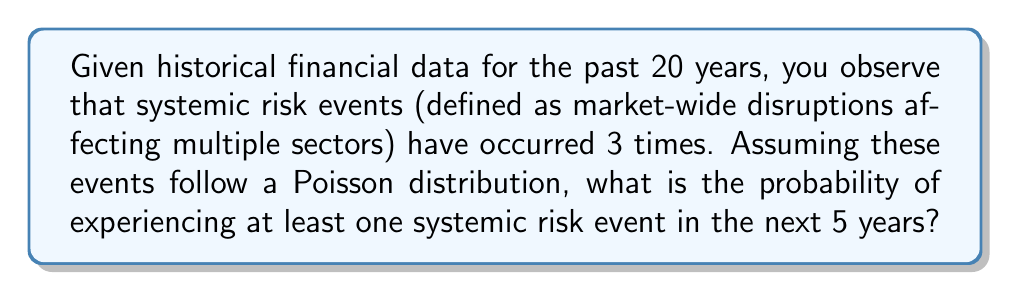Can you solve this math problem? To solve this problem, we'll follow these steps:

1. Calculate the rate parameter (λ) for the Poisson distribution:
   λ = (Number of events) / (Time period)
   λ = 3 / 20 = 0.15 events per year

2. Adjust λ for the 5-year period we're interested in:
   λ_5 = 0.15 * 5 = 0.75

3. The probability of at least one event is the complement of the probability of zero events:
   P(X ≥ 1) = 1 - P(X = 0)

4. Use the Poisson probability mass function for P(X = 0):
   P(X = k) = (e^(-λ) * λ^k) / k!
   P(X = 0) = e^(-λ) * λ^0 / 0! = e^(-λ)

5. Calculate the final probability:
   P(X ≥ 1) = 1 - e^(-λ_5)
   P(X ≥ 1) = 1 - e^(-0.75)
   P(X ≥ 1) ≈ 0.5276

Therefore, the probability of experiencing at least one systemic risk event in the next 5 years is approximately 0.5276 or 52.76%.
Answer: $1 - e^{-0.75} \approx 0.5276$ 